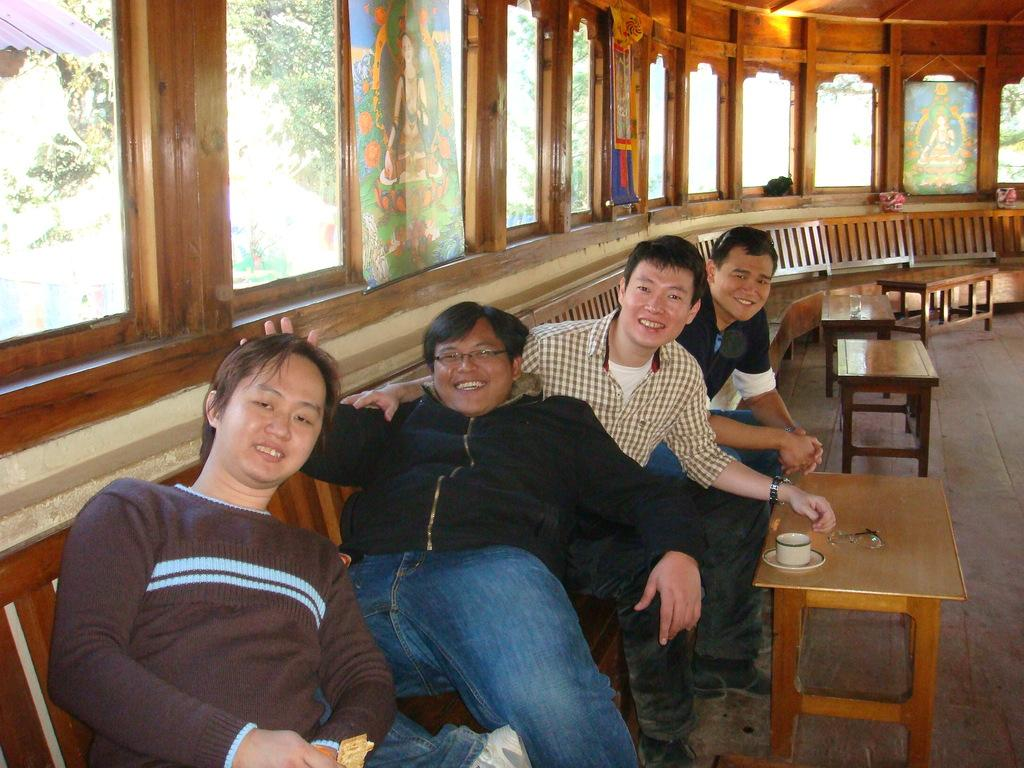How many individuals are present in the image? There are four people in the image. What are the people doing in the image? The people are sitting on chairs. Is there any furniture in front of the people? Yes, there is a table in front of the people. What type of stick can be seen in the hands of the people in the image? There is no stick present in the hands of the people in the image. 